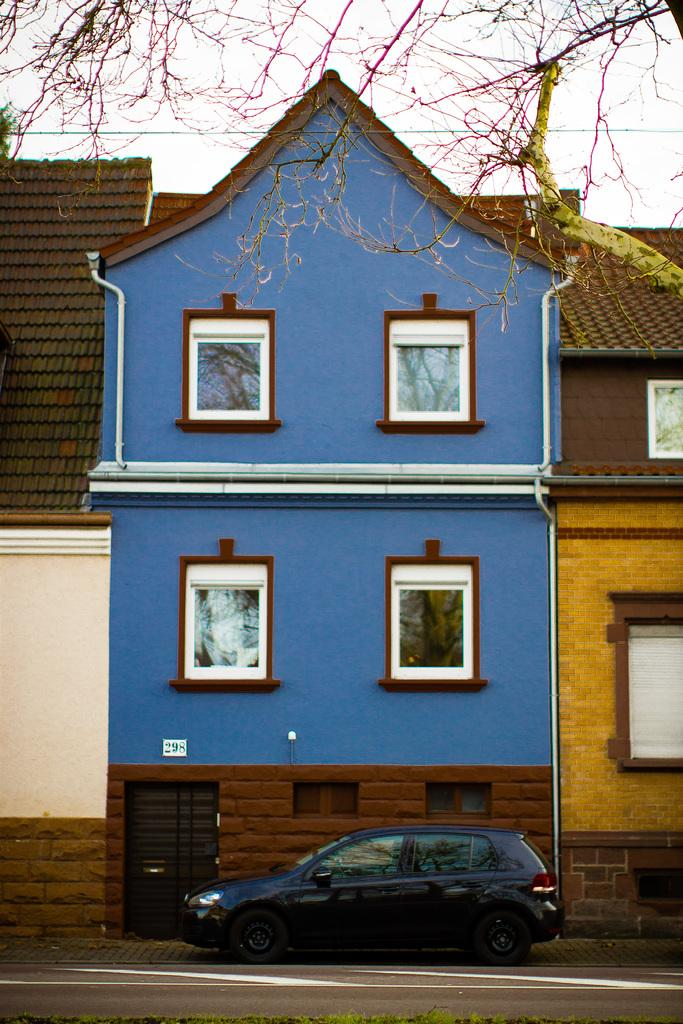What is located in the center of the image? There are buildings in the center of the image. What can be seen at the bottom of the image? There is a car and a road at the bottom of the image. What is visible at the top of the image? There are trees at the top of the image. Can you tell me how many pears are on the trees at the top of the image? There are no pears present in the image; it only features trees. What type of appliance is visible in the image? There is no appliance present in the image. 